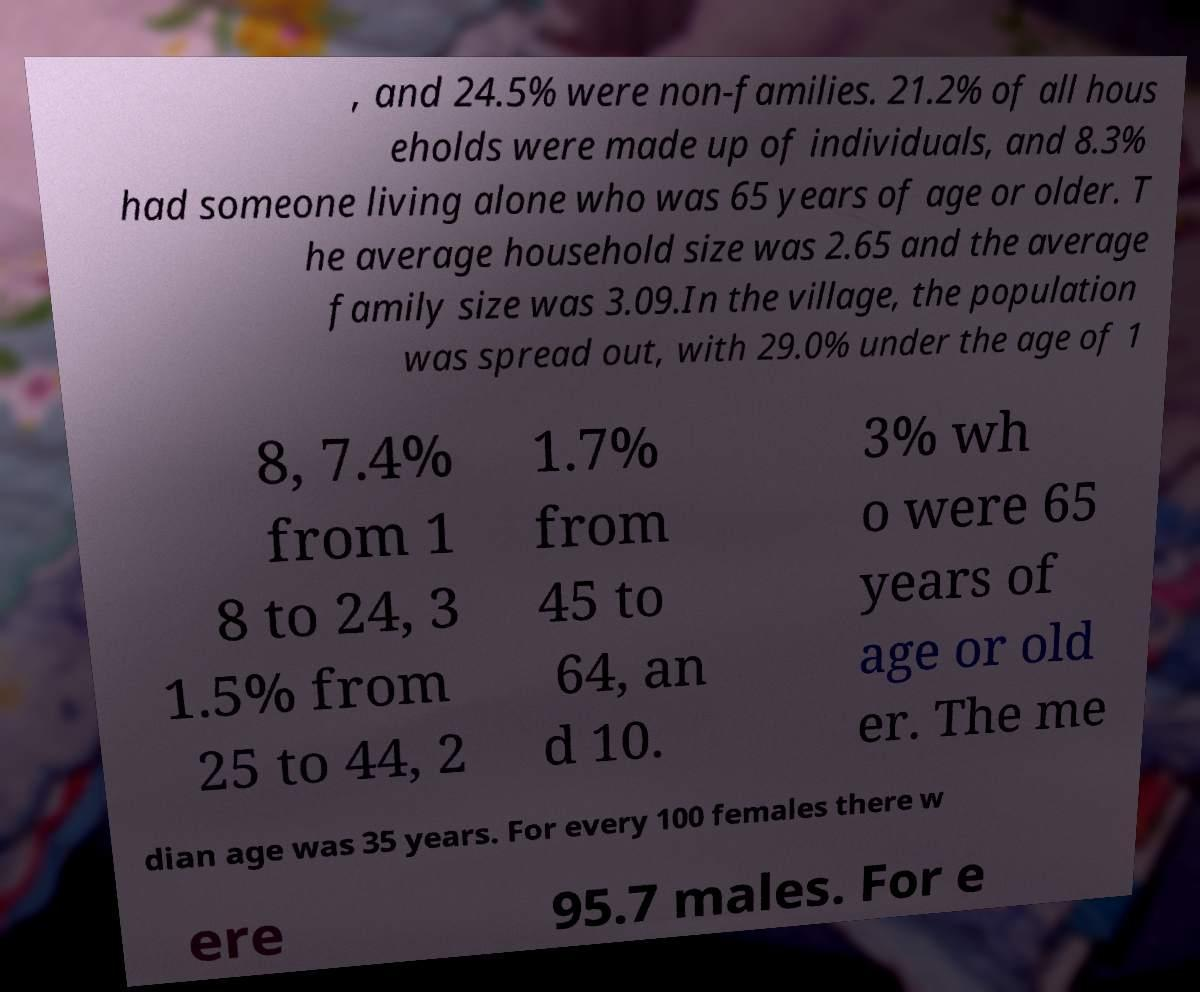I need the written content from this picture converted into text. Can you do that? , and 24.5% were non-families. 21.2% of all hous eholds were made up of individuals, and 8.3% had someone living alone who was 65 years of age or older. T he average household size was 2.65 and the average family size was 3.09.In the village, the population was spread out, with 29.0% under the age of 1 8, 7.4% from 1 8 to 24, 3 1.5% from 25 to 44, 2 1.7% from 45 to 64, an d 10. 3% wh o were 65 years of age or old er. The me dian age was 35 years. For every 100 females there w ere 95.7 males. For e 